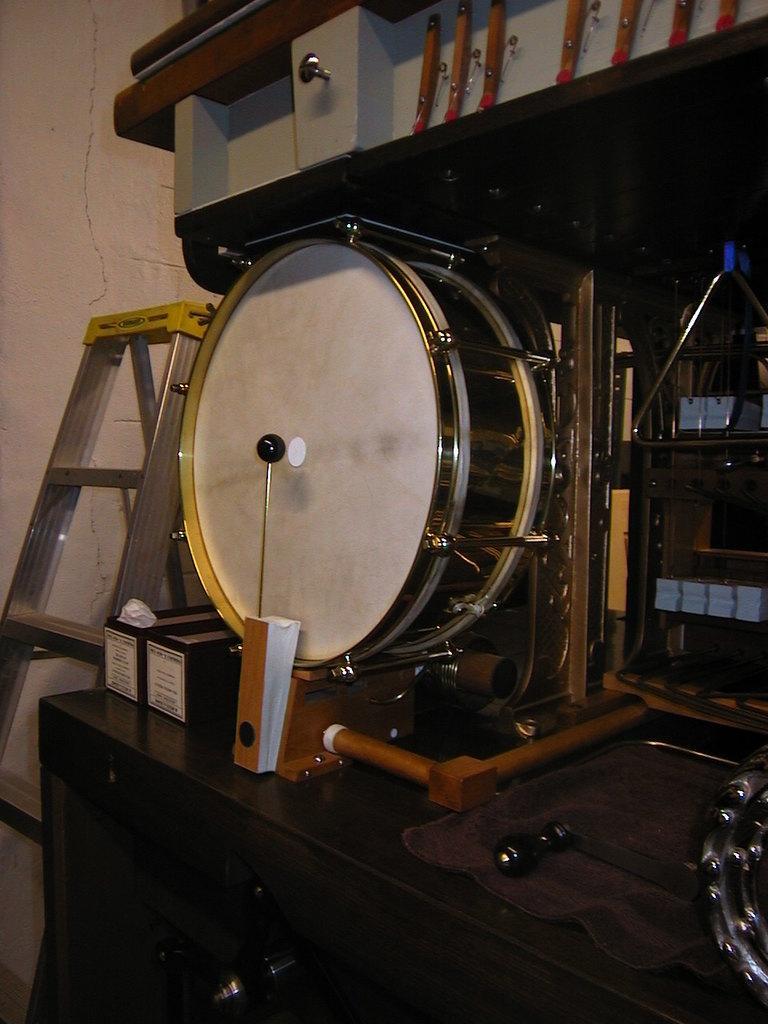Can you describe this image briefly? In this image I can see a black colored table and on the table I can see a musical instrument and few other objects. In the background I can see a ladder and the wall. 